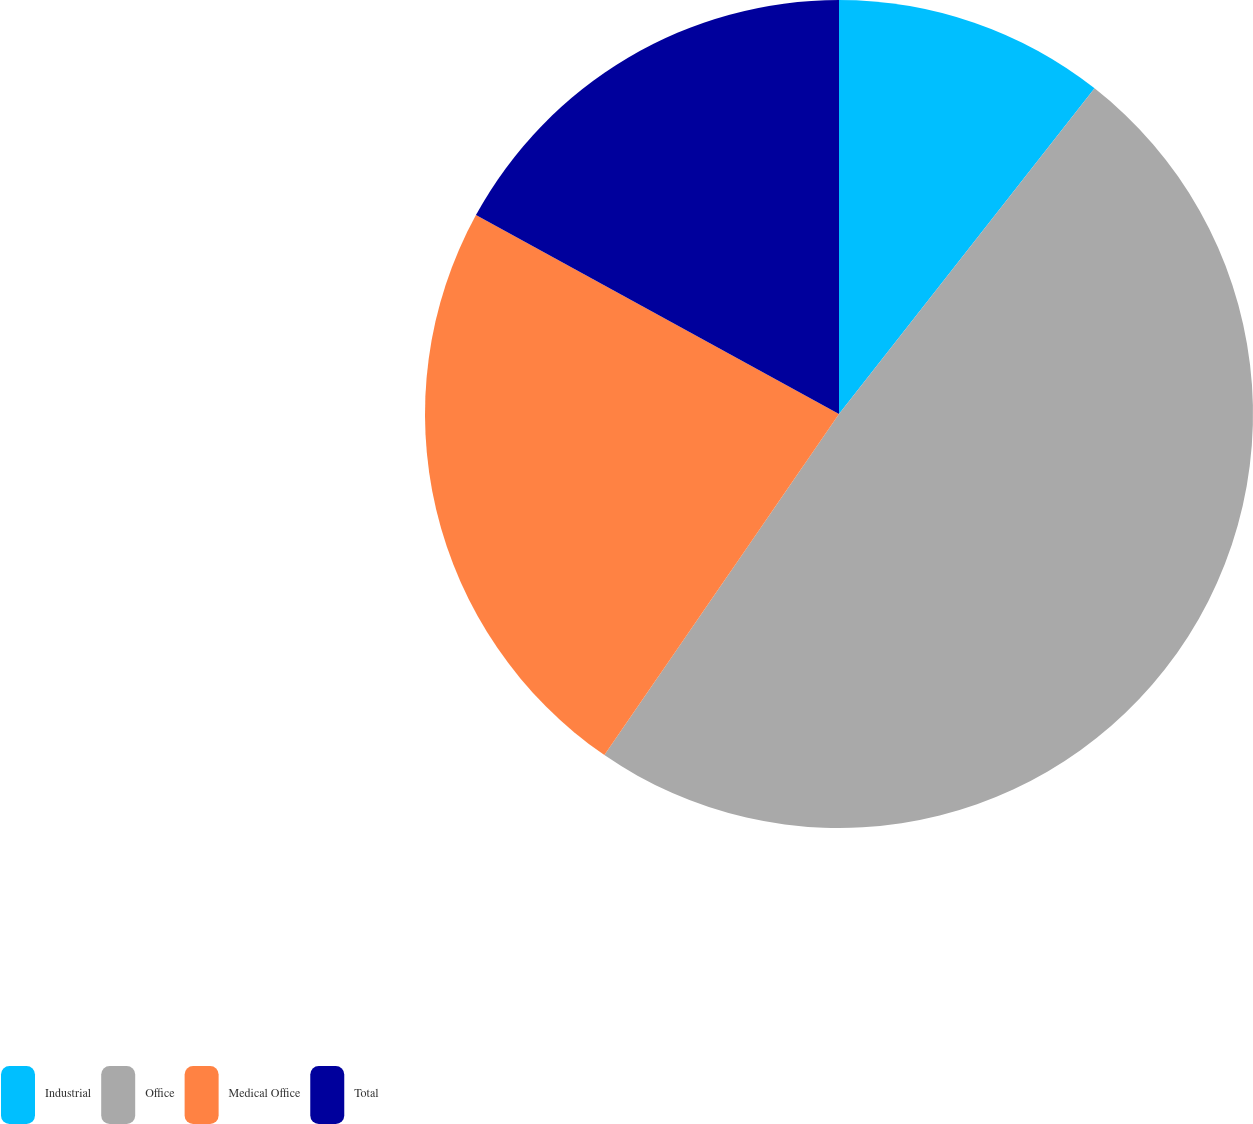Convert chart to OTSL. <chart><loc_0><loc_0><loc_500><loc_500><pie_chart><fcel>Industrial<fcel>Office<fcel>Medical Office<fcel>Total<nl><fcel>10.59%<fcel>49.0%<fcel>23.39%<fcel>17.02%<nl></chart> 